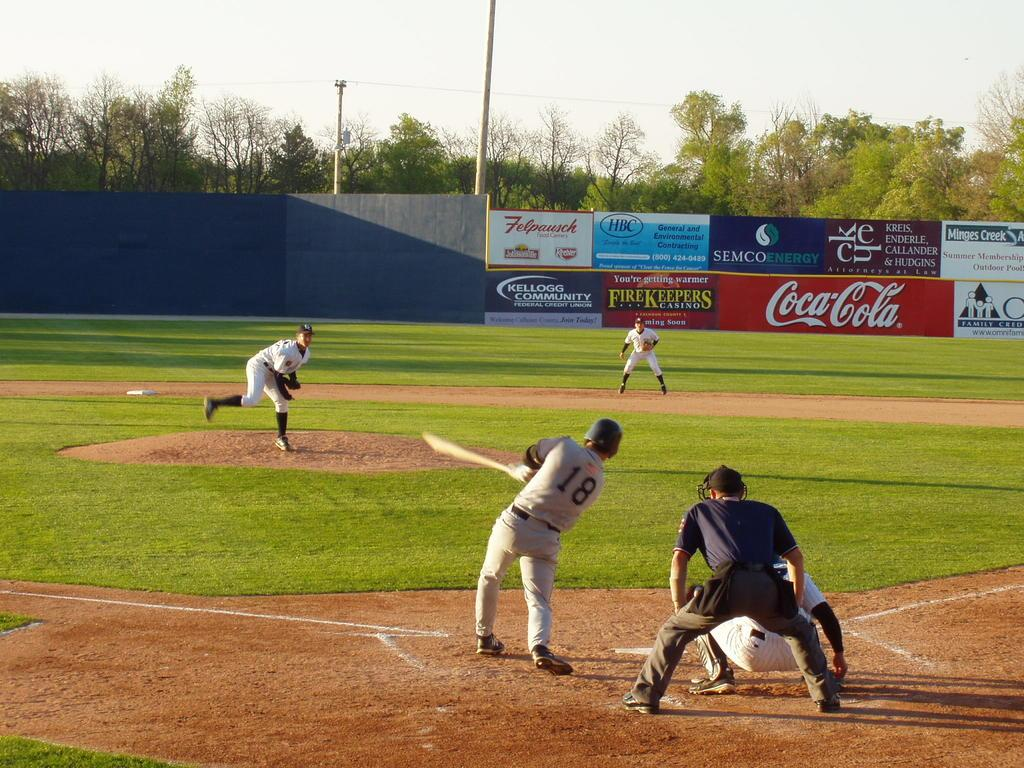Provide a one-sentence caption for the provided image. A baseball player wearing the number 18 hits a baseball. 